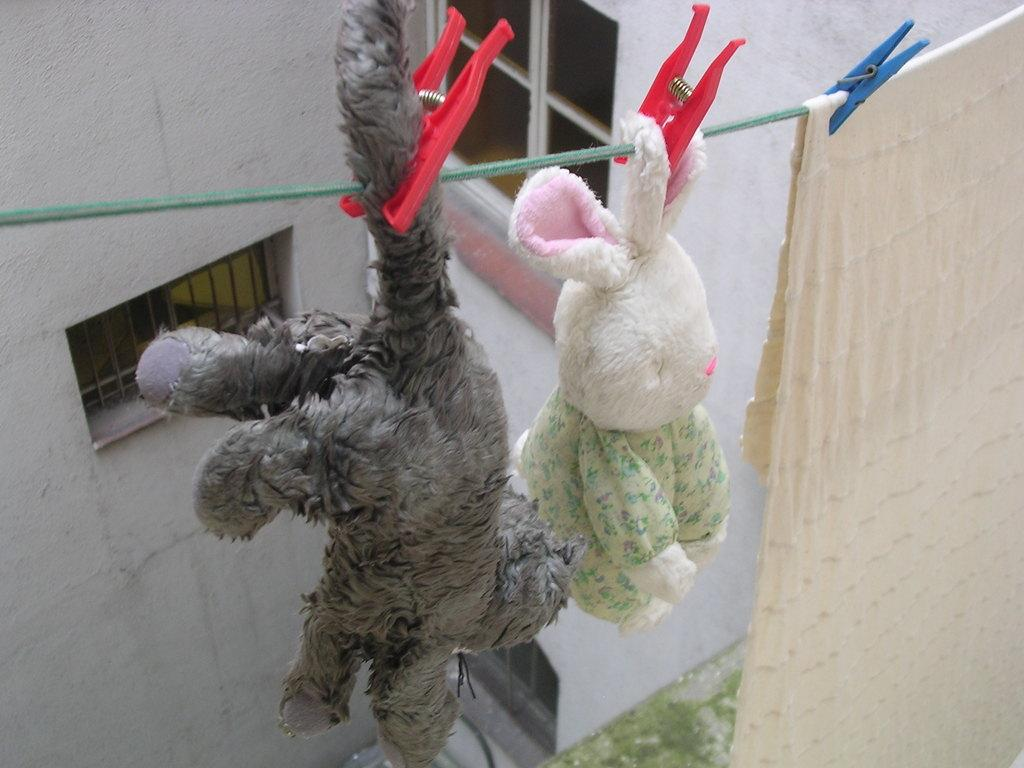What type of objects can be seen in the image? There are soft toys in the image. Can you describe the cloth in the image? The cloth is hanging on a rope with the help of clips. What can be seen in the background of the image? There is a building in the background of the image. What type of leather is used to make the soft toys in the image? The soft toys in the image are not made of leather; they are made of fabric or other materials. What selection of soft toys is available in the image? The image only shows a few soft toys, so it is not possible to determine the full selection. 